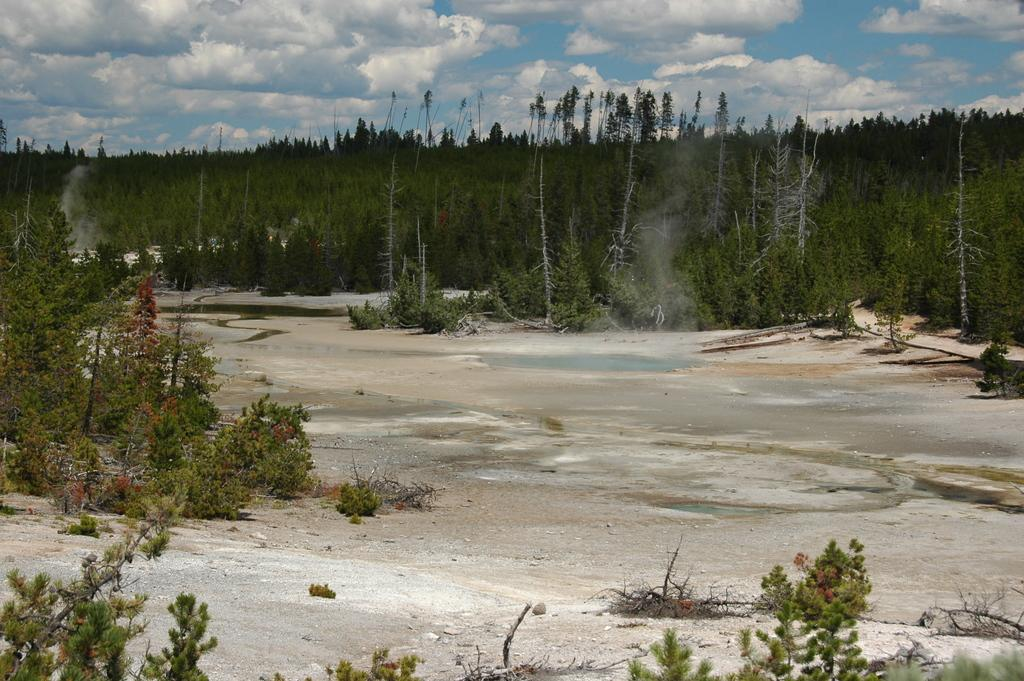What type of natural elements are present in the image? There are many trees and plants in the image. What part of the natural environment is visible in the image? The sky is visible in the image. Can you describe the appearance of the sky in the image? The sky appears to be cloudy and pale blue. What type of songs can be heard coming from the trees in the image? There are no songs present in the image; it is a natural scene featuring trees, plants, and a cloudy, pale blue sky. 